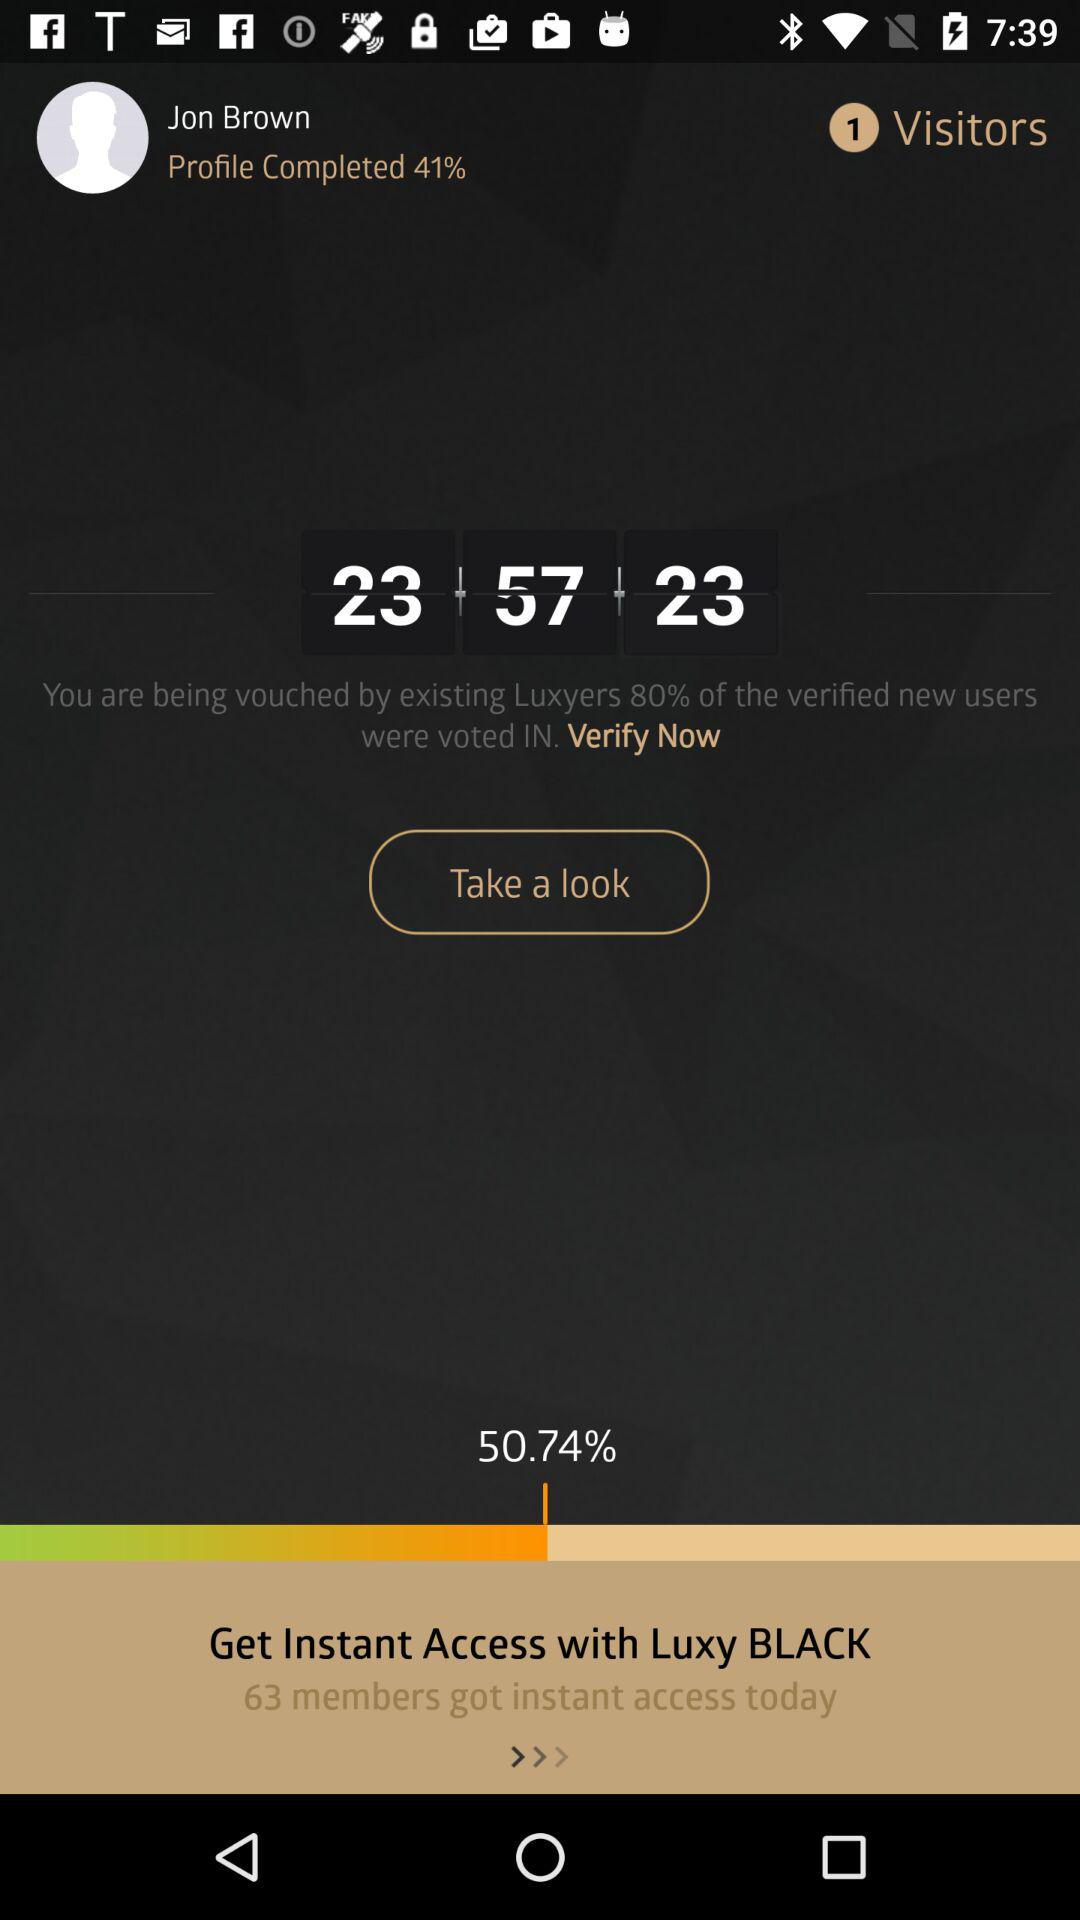How many visitors are shown? There is 1 visitor. 